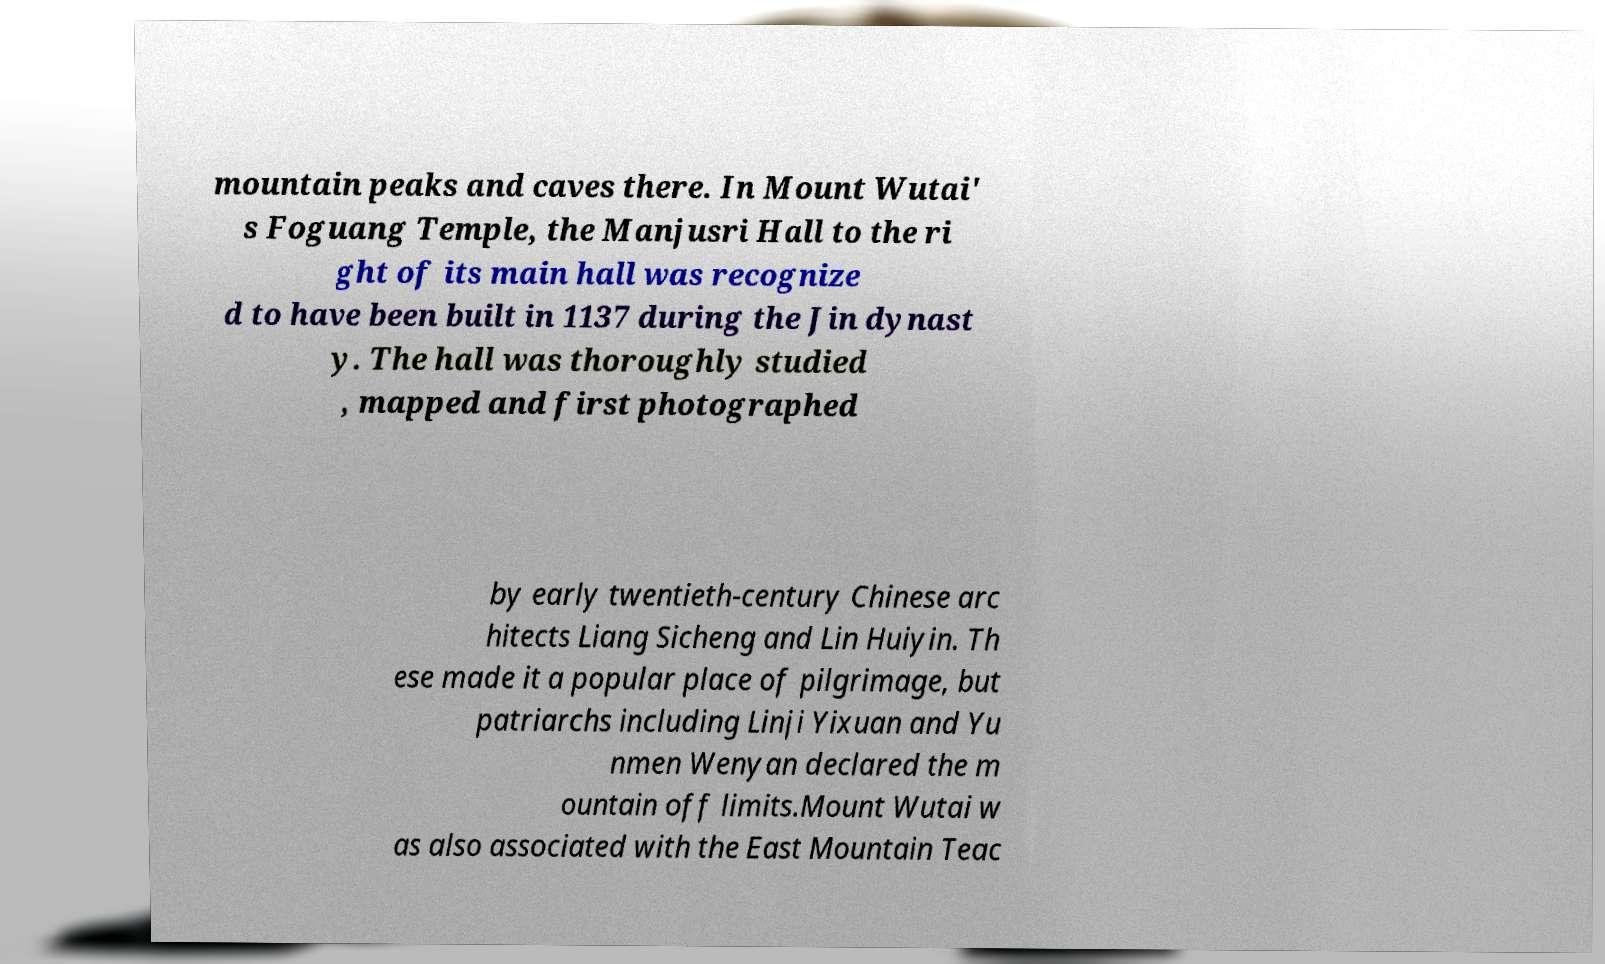There's text embedded in this image that I need extracted. Can you transcribe it verbatim? mountain peaks and caves there. In Mount Wutai' s Foguang Temple, the Manjusri Hall to the ri ght of its main hall was recognize d to have been built in 1137 during the Jin dynast y. The hall was thoroughly studied , mapped and first photographed by early twentieth-century Chinese arc hitects Liang Sicheng and Lin Huiyin. Th ese made it a popular place of pilgrimage, but patriarchs including Linji Yixuan and Yu nmen Wenyan declared the m ountain off limits.Mount Wutai w as also associated with the East Mountain Teac 